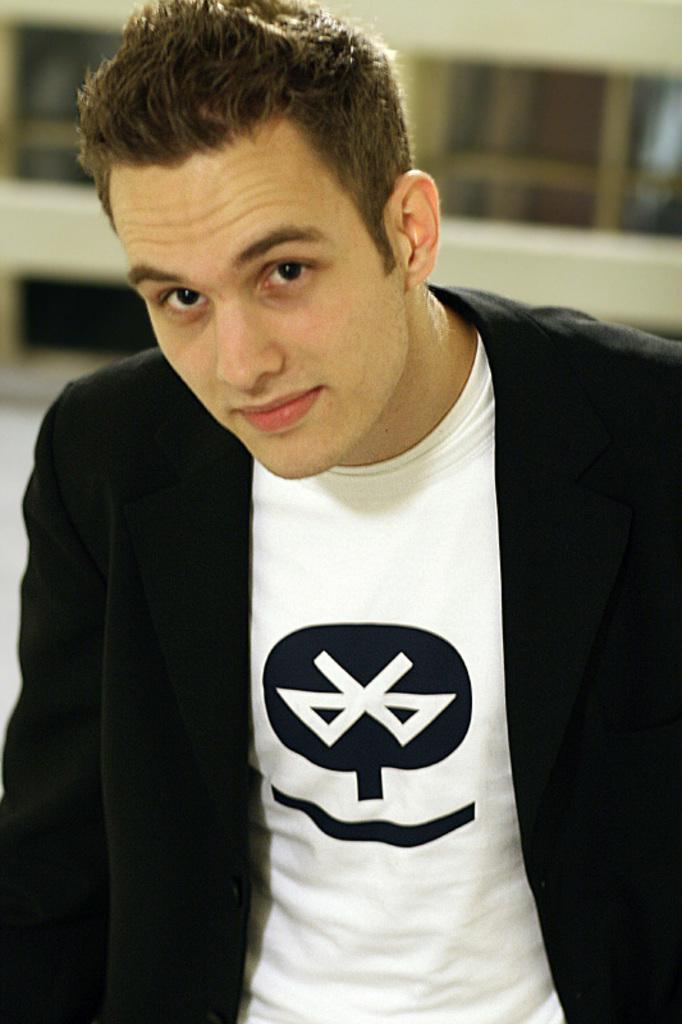Who is present in the image? There is a man in the image. What can be seen in the background of the image? There is a building in the background of the image. How is the building depicted in the image? The building is blurry in the image. What type of pollution can be seen coming from the vase in the background? There is no vase present in the image, and therefore no pollution can be observed. 